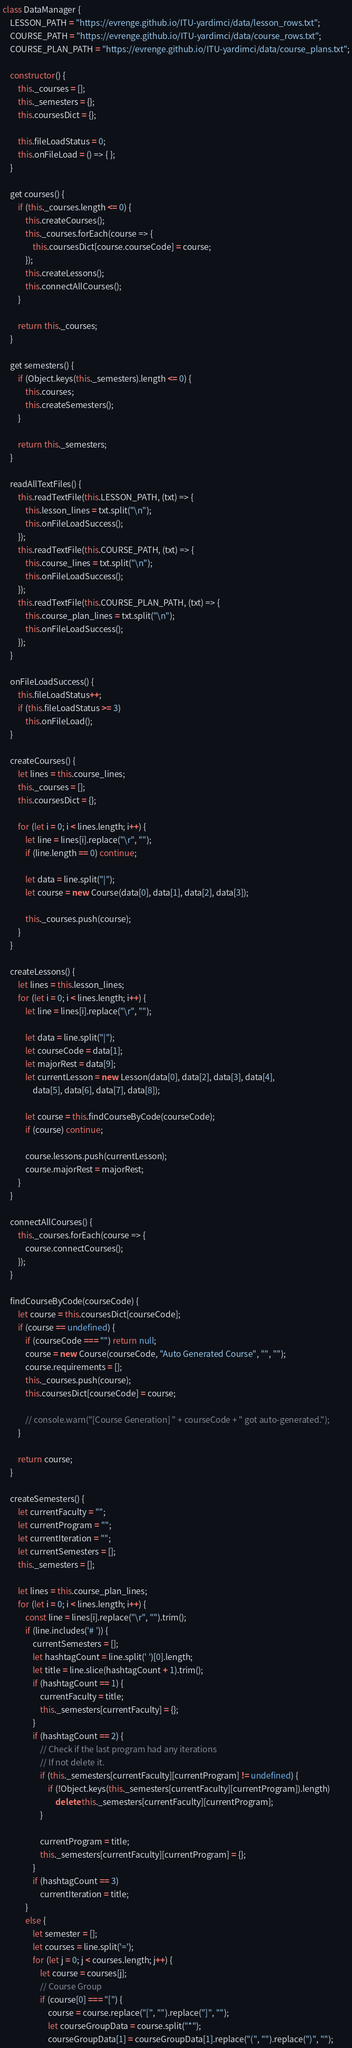<code> <loc_0><loc_0><loc_500><loc_500><_JavaScript_>class DataManager {
    LESSON_PATH = "https://evrenge.github.io/ITU-yardimci/data/lesson_rows.txt";
    COURSE_PATH = "https://evrenge.github.io/ITU-yardimci/data/course_rows.txt";
    COURSE_PLAN_PATH = "https://evrenge.github.io/ITU-yardimci/data/course_plans.txt";

    constructor() {
        this._courses = [];
        this._semesters = {};
        this.coursesDict = {};

        this.fileLoadStatus = 0;
        this.onFileLoad = () => { };
    }

    get courses() {
        if (this._courses.length <= 0) {
            this.createCourses();
            this._courses.forEach(course => {
                this.coursesDict[course.courseCode] = course;
            });
            this.createLessons();
            this.connectAllCourses();
        }

        return this._courses;
    }

    get semesters() {
        if (Object.keys(this._semesters).length <= 0) {
            this.courses;
            this.createSemesters();
        }

        return this._semesters;
    }

    readAllTextFiles() {
        this.readTextFile(this.LESSON_PATH, (txt) => {
            this.lesson_lines = txt.split("\n");
            this.onFileLoadSuccess();
        });
        this.readTextFile(this.COURSE_PATH, (txt) => {
            this.course_lines = txt.split("\n");
            this.onFileLoadSuccess();
        });
        this.readTextFile(this.COURSE_PLAN_PATH, (txt) => {
            this.course_plan_lines = txt.split("\n");
            this.onFileLoadSuccess();
        });
    }

    onFileLoadSuccess() {
        this.fileLoadStatus++;
        if (this.fileLoadStatus >= 3)
            this.onFileLoad();
    }

    createCourses() {
        let lines = this.course_lines;
        this._courses = [];
        this.coursesDict = {};

        for (let i = 0; i < lines.length; i++) {
            let line = lines[i].replace("\r", "");
            if (line.length == 0) continue;

            let data = line.split("|");
            let course = new Course(data[0], data[1], data[2], data[3]);

            this._courses.push(course);
        }
    }

    createLessons() {
        let lines = this.lesson_lines;
        for (let i = 0; i < lines.length; i++) {
            let line = lines[i].replace("\r", "");

            let data = line.split("|");
            let courseCode = data[1];
            let majorRest = data[9];
            let currentLesson = new Lesson(data[0], data[2], data[3], data[4],
                data[5], data[6], data[7], data[8]);

            let course = this.findCourseByCode(courseCode);
            if (course) continue;

            course.lessons.push(currentLesson);
            course.majorRest = majorRest;
        }
    }

    connectAllCourses() {
        this._courses.forEach(course => {
            course.connectCourses();
        });
    }

    findCourseByCode(courseCode) {
        let course = this.coursesDict[courseCode];
        if (course == undefined) {
            if (courseCode === "") return null;
            course = new Course(courseCode, "Auto Generated Course", "", "");
            course.requirements = [];
            this._courses.push(course);
            this.coursesDict[courseCode] = course;

            // console.warn("[Course Generation] " + courseCode + " got auto-generated.");
        }

        return course;
    }

    createSemesters() {
        let currentFaculty = "";
        let currentProgram = "";
        let currentIteration = "";
        let currentSemesters = [];
        this._semesters = [];

        let lines = this.course_plan_lines;
        for (let i = 0; i < lines.length; i++) {
            const line = lines[i].replace("\r", "").trim();
            if (line.includes('# ')) {
                currentSemesters = [];
                let hashtagCount = line.split(' ')[0].length;
                let title = line.slice(hashtagCount + 1).trim();
                if (hashtagCount == 1) {
                    currentFaculty = title;
                    this._semesters[currentFaculty] = {};
                }
                if (hashtagCount == 2) {
                    // Check if the last program had any iterations
                    // If not delete it.
                    if (this._semesters[currentFaculty][currentProgram] != undefined) {
                        if (!Object.keys(this._semesters[currentFaculty][currentProgram]).length)
                            delete this._semesters[currentFaculty][currentProgram];
                    }

                    currentProgram = title;
                    this._semesters[currentFaculty][currentProgram] = {};
                }
                if (hashtagCount == 3)
                    currentIteration = title;
            }
            else {
                let semester = [];
                let courses = line.split('=');
                for (let j = 0; j < courses.length; j++) {
                    let course = courses[j];
                    // Course Group
                    if (course[0] === "[") {
                        course = course.replace("[", "").replace("]", "");
                        let courseGroupData = course.split("*");
                        courseGroupData[1] = courseGroupData[1].replace("(", "").replace(")", "");</code> 